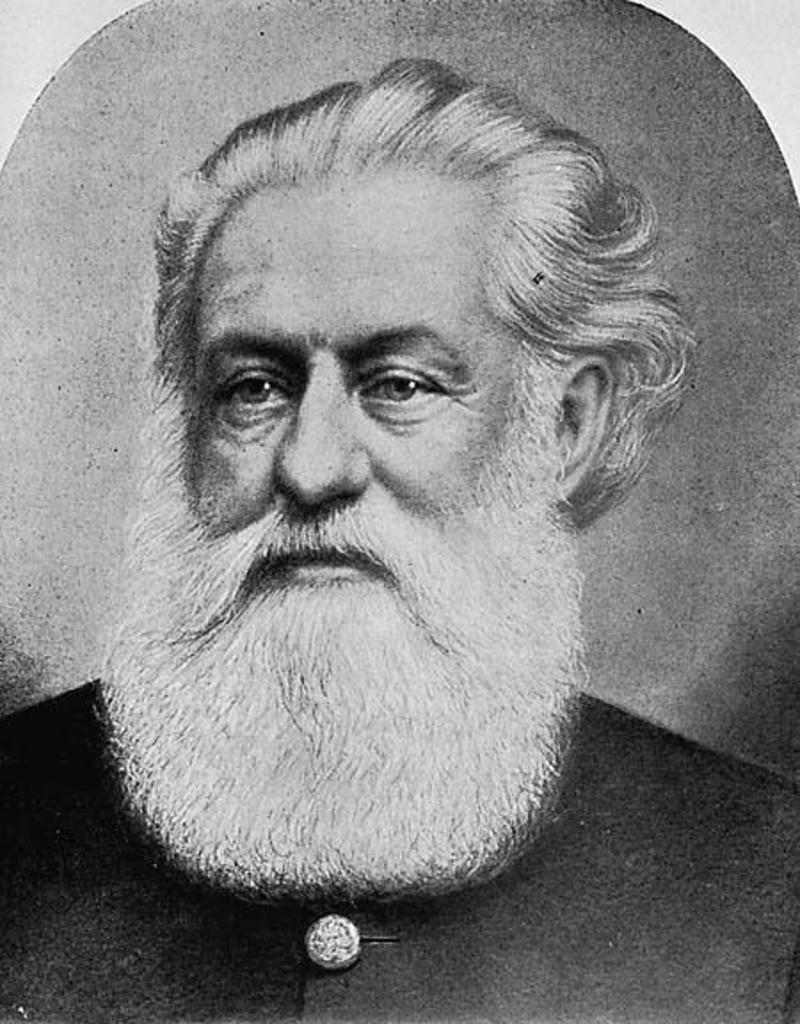Can you describe this image briefly? This is a black and white image, in this image in the center there is one person with beard. 